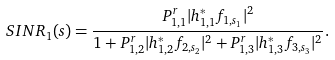Convert formula to latex. <formula><loc_0><loc_0><loc_500><loc_500>S I N R _ { 1 } ( s ) = \frac { P ^ { r } _ { 1 , 1 } | h _ { 1 , 1 } ^ { * } f _ { 1 , s _ { 1 } } | ^ { 2 } } { 1 + P ^ { r } _ { 1 , 2 } | h _ { 1 , 2 } ^ { * } f _ { 2 , s _ { 2 } } | ^ { 2 } + P ^ { r } _ { 1 , 3 } | h _ { 1 , 3 } ^ { * } f _ { 3 , s _ { 3 } } | ^ { 2 } } .</formula> 